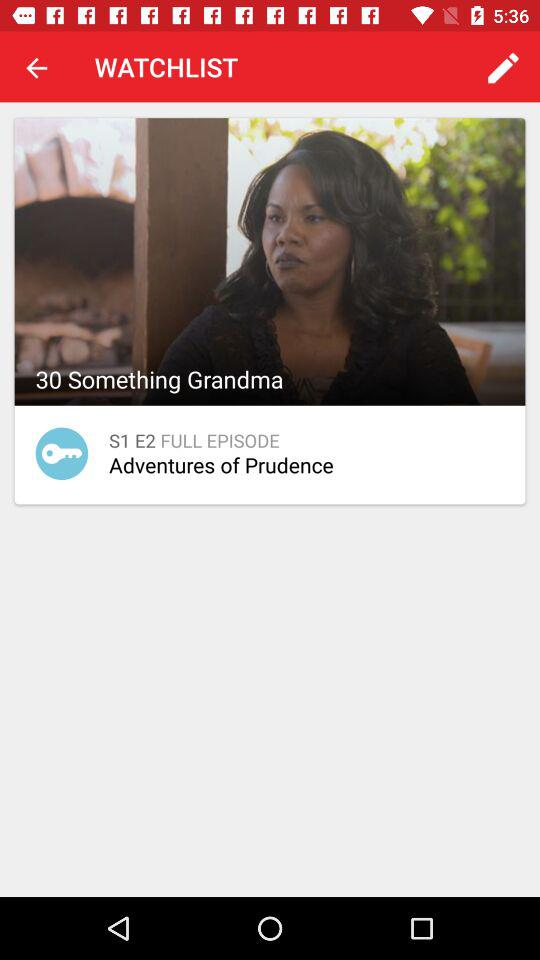What is the name of the series? The name of the series is "30 Something Grandma". 